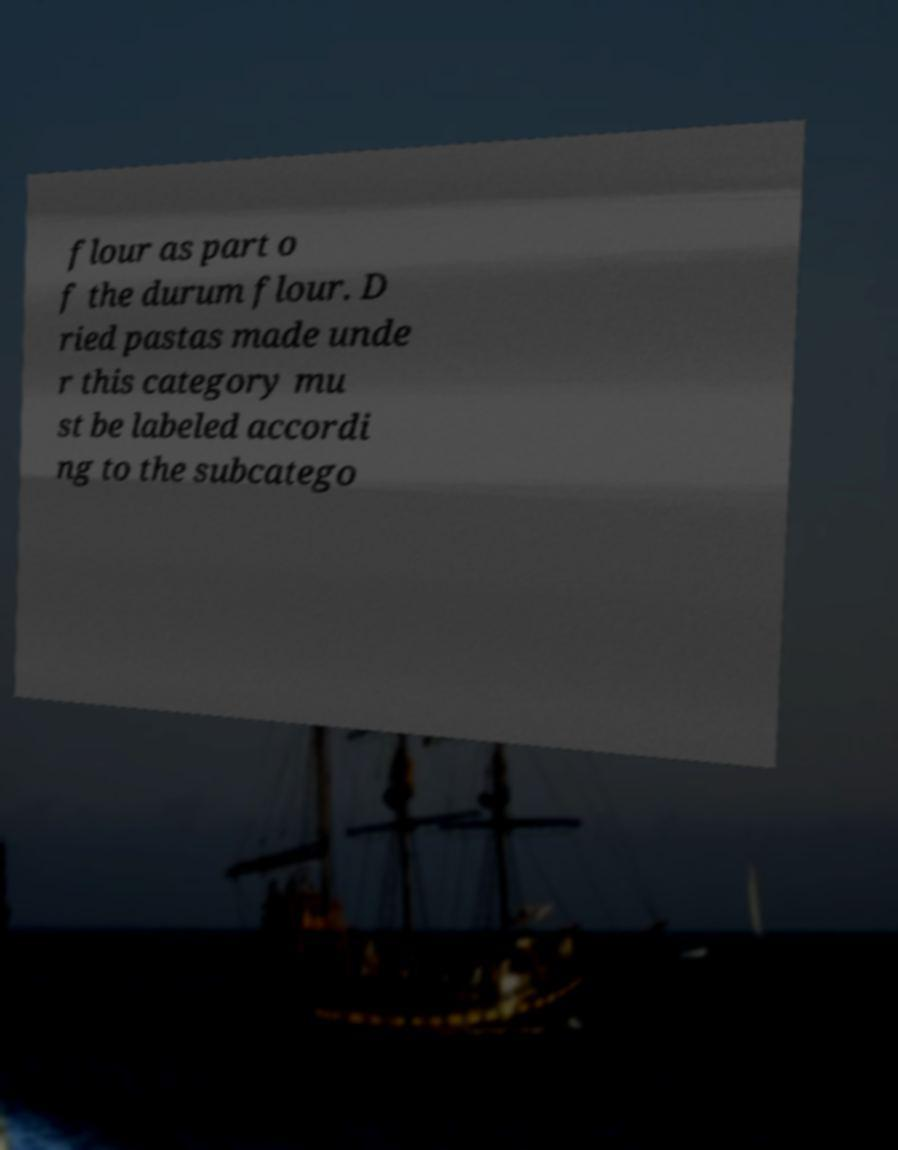Could you extract and type out the text from this image? flour as part o f the durum flour. D ried pastas made unde r this category mu st be labeled accordi ng to the subcatego 